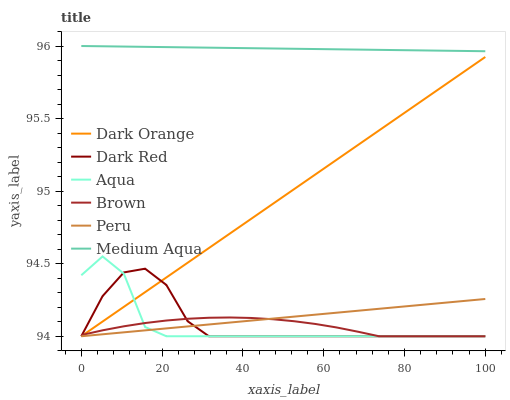Does Brown have the minimum area under the curve?
Answer yes or no. Yes. Does Medium Aqua have the maximum area under the curve?
Answer yes or no. Yes. Does Dark Red have the minimum area under the curve?
Answer yes or no. No. Does Dark Red have the maximum area under the curve?
Answer yes or no. No. Is Peru the smoothest?
Answer yes or no. Yes. Is Aqua the roughest?
Answer yes or no. Yes. Is Brown the smoothest?
Answer yes or no. No. Is Brown the roughest?
Answer yes or no. No. Does Dark Orange have the lowest value?
Answer yes or no. Yes. Does Medium Aqua have the lowest value?
Answer yes or no. No. Does Medium Aqua have the highest value?
Answer yes or no. Yes. Does Dark Red have the highest value?
Answer yes or no. No. Is Aqua less than Medium Aqua?
Answer yes or no. Yes. Is Medium Aqua greater than Peru?
Answer yes or no. Yes. Does Peru intersect Dark Red?
Answer yes or no. Yes. Is Peru less than Dark Red?
Answer yes or no. No. Is Peru greater than Dark Red?
Answer yes or no. No. Does Aqua intersect Medium Aqua?
Answer yes or no. No. 